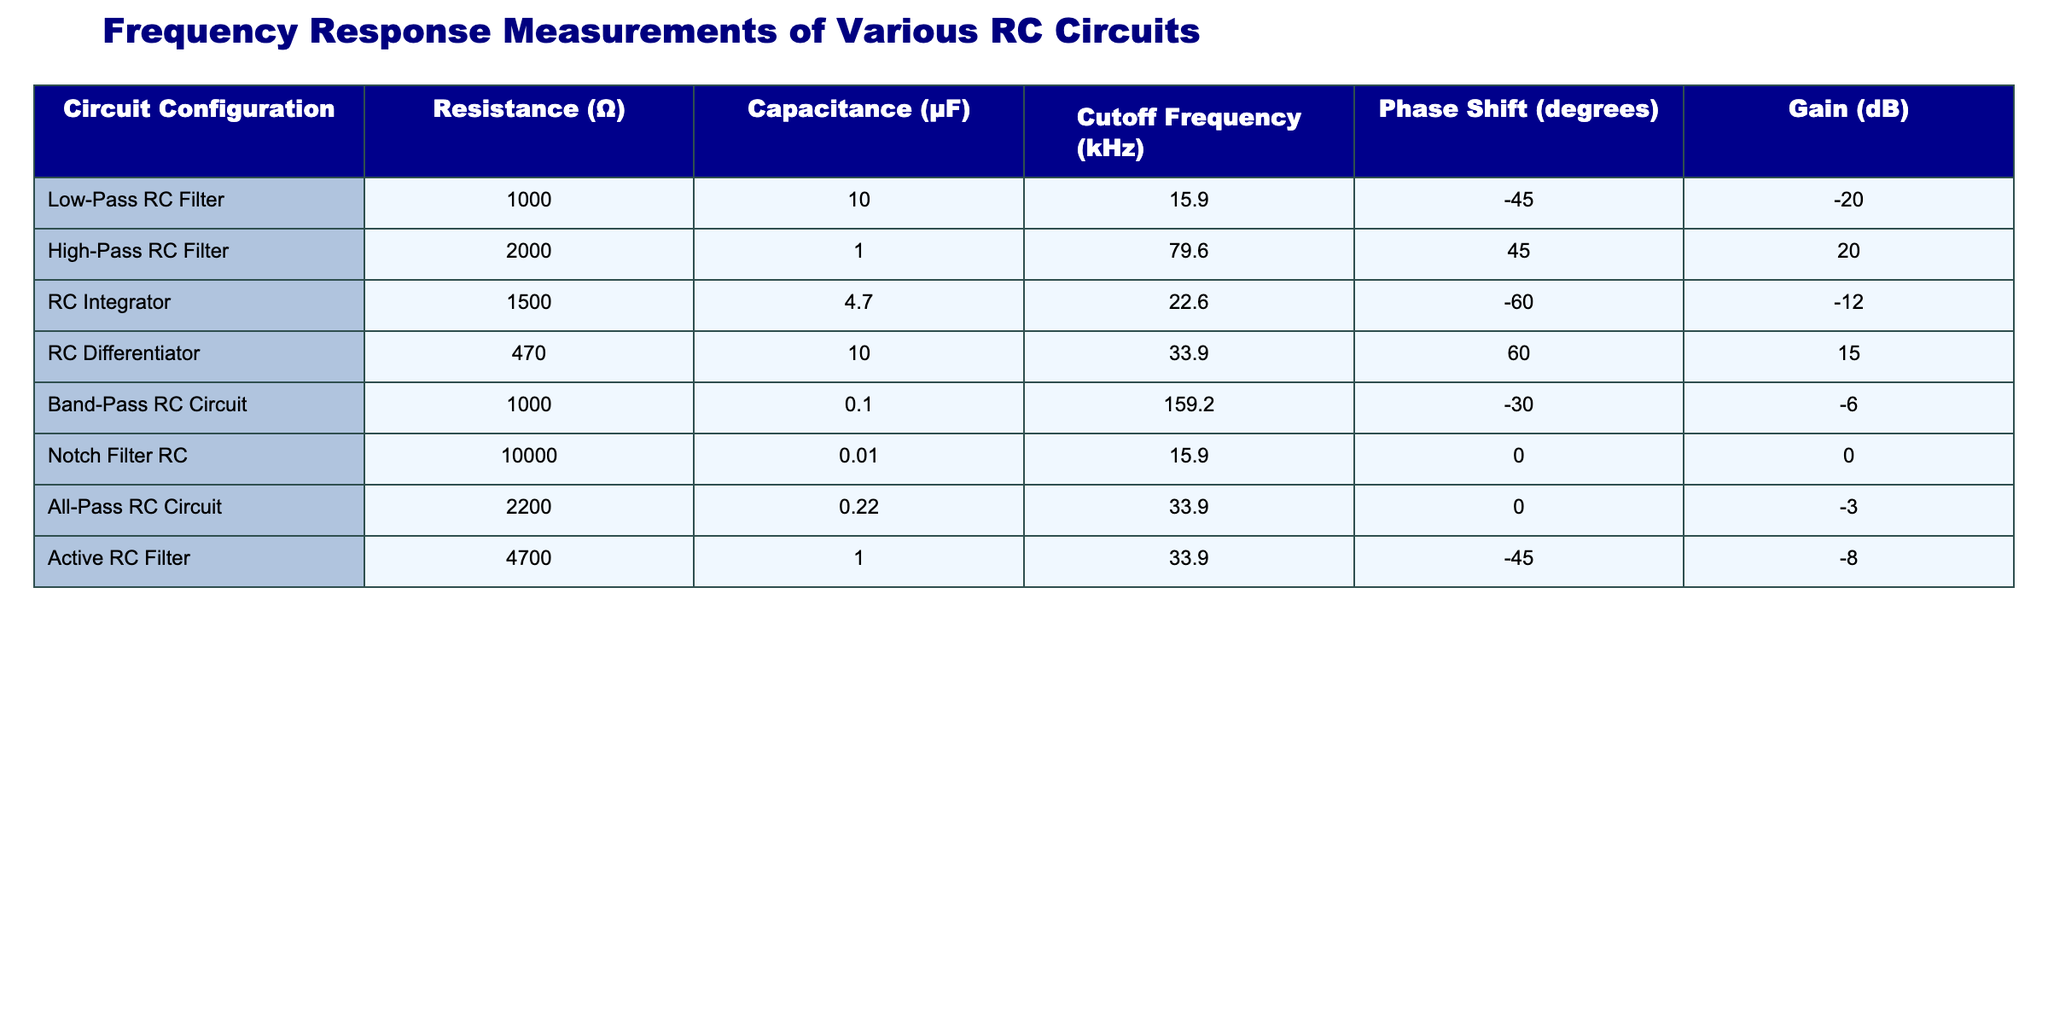What is the cutoff frequency of the Low-Pass RC Filter? The Low-Pass RC Filter is listed in the table, and its cutoff frequency is provided in the corresponding column. According to the table, the cutoff frequency for the Low-Pass RC Filter is 15.9 kHz.
Answer: 15.9 kHz How many circuits have a gain greater than 0 dB? By examining the Gain column, we see that the High-Pass RC Filter (20 dB), the RC Differentiator (15 dB), and the Band-Pass RC Circuit (-6 dB) have gains. The High-Pass RC Filter and RC Differentiator are the only circuits with gains greater than 0 dB. Therefore, there are two circuits.
Answer: 2 What is the average resistance of the circuits listed in the table? To find the average resistance, sum all the resistance values: 1000 + 2000 + 1500 + 470 + 1000 + 10000 + 2200 + 4700 = 19000 ohms. Then, divide this by the number of circuits, which is 8. Therefore, 19000 / 8 = 2375 ohms.
Answer: 2375 Ω Which circuit has the highest cutoff frequency, and what is that frequency? Checking the Cutoff Frequency column, we compare all the values. The Band-Pass RC Circuit has the highest value at 159.2 kHz. Thus, the highest cutoff frequency among all circuits is 159.2 kHz located in the Band-Pass RC Circuit.
Answer: 159.2 kHz Is there a circuit with a phase shift of 0 degrees? If so, which one? Looking through the Phase Shift column reveals that the Notch Filter RC has a phase shift of 0 degrees. Therefore, yes, there is a circuit with a phase shift of 0 degrees, and that circuit is the Notch Filter RC.
Answer: Yes, Notch Filter RC What is the difference in cutoff frequency between the High-Pass and Low-Pass RC Filters? The cutoff frequency for the High-Pass RC Filter is 79.6 kHz, while for the Low-Pass RC Filter, it is 15.9 kHz. To find the difference, we subtract: 79.6 - 15.9 = 63.7 kHz.
Answer: 63.7 kHz Which circuit has the lowest gain, and what is its value? Upon reviewing the Gain column, the RC Integrator shows the lowest figure at -12 dB. Thus, the circuit with the lowest gain is the RC Integrator with a gain of -12 dB.
Answer: RC Integrator, -12 dB How does the phase shift of the RC Differentiator compare to that of the Active RC Filter? The phase shift for the RC Differentiator is 60 degrees and for the Active RC Filter, it is -45 degrees. Comparing these values reveals that the RC Differentiator has a higher phase shift (positive) compared to the Active RC Filter, which has a negative phase shift.
Answer: RC Differentiator has a higher phase shift What is the relationship between resistance and cutoff frequency in this table? To analyze the relationship, we can assess trends in both columns. The Lower the resistance, typically, the higher the cutoff frequency value is for most circuits. This indicates an inverse relationship.
Answer: Inverse relationship; lower resistance typically leads to higher cutoff frequency 